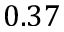<formula> <loc_0><loc_0><loc_500><loc_500>0 . 3 7</formula> 